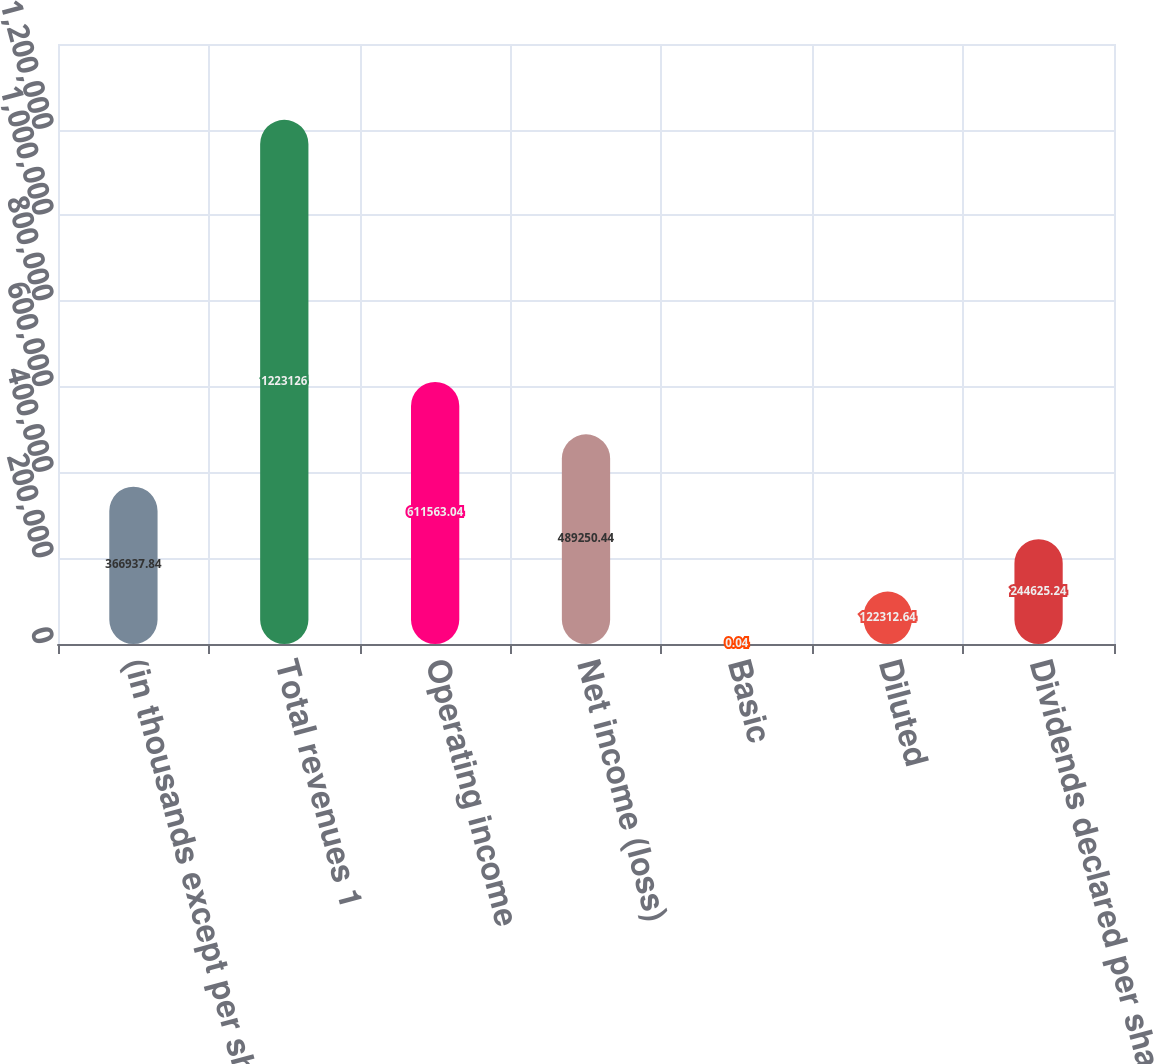Convert chart to OTSL. <chart><loc_0><loc_0><loc_500><loc_500><bar_chart><fcel>(in thousands except per share<fcel>Total revenues 1<fcel>Operating income<fcel>Net income (loss)<fcel>Basic<fcel>Diluted<fcel>Dividends declared per share<nl><fcel>366938<fcel>1.22313e+06<fcel>611563<fcel>489250<fcel>0.04<fcel>122313<fcel>244625<nl></chart> 